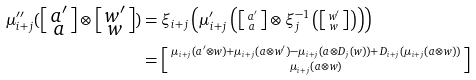<formula> <loc_0><loc_0><loc_500><loc_500>\mu ^ { \prime \prime } _ { i + j } ( \left [ \begin{smallmatrix} a ^ { \prime } \\ a \end{smallmatrix} \right ] \otimes \left [ \begin{smallmatrix} w ^ { \prime } \\ w \end{smallmatrix} \right ] ) & = \xi _ { i + j } \left ( \mu ^ { \prime } _ { i + j } \left ( \left [ \begin{smallmatrix} a ^ { \prime } \\ a \end{smallmatrix} \right ] \otimes \xi _ { j } ^ { - 1 } \left ( \left [ \begin{smallmatrix} w ^ { \prime } \\ w \end{smallmatrix} \right ] \right ) \right ) \right ) \\ & = \left [ \begin{smallmatrix} \mu _ { i + j } ( a ^ { \prime } \otimes w ) + \mu _ { i + j } ( a \otimes w ^ { \prime } ) - \mu _ { i + j } ( a \otimes D _ { j } ( w ) ) + D _ { i + j } ( \mu _ { i + j } ( a \otimes w ) ) \\ \mu _ { i + j } ( a \otimes w ) \end{smallmatrix} \right ]</formula> 